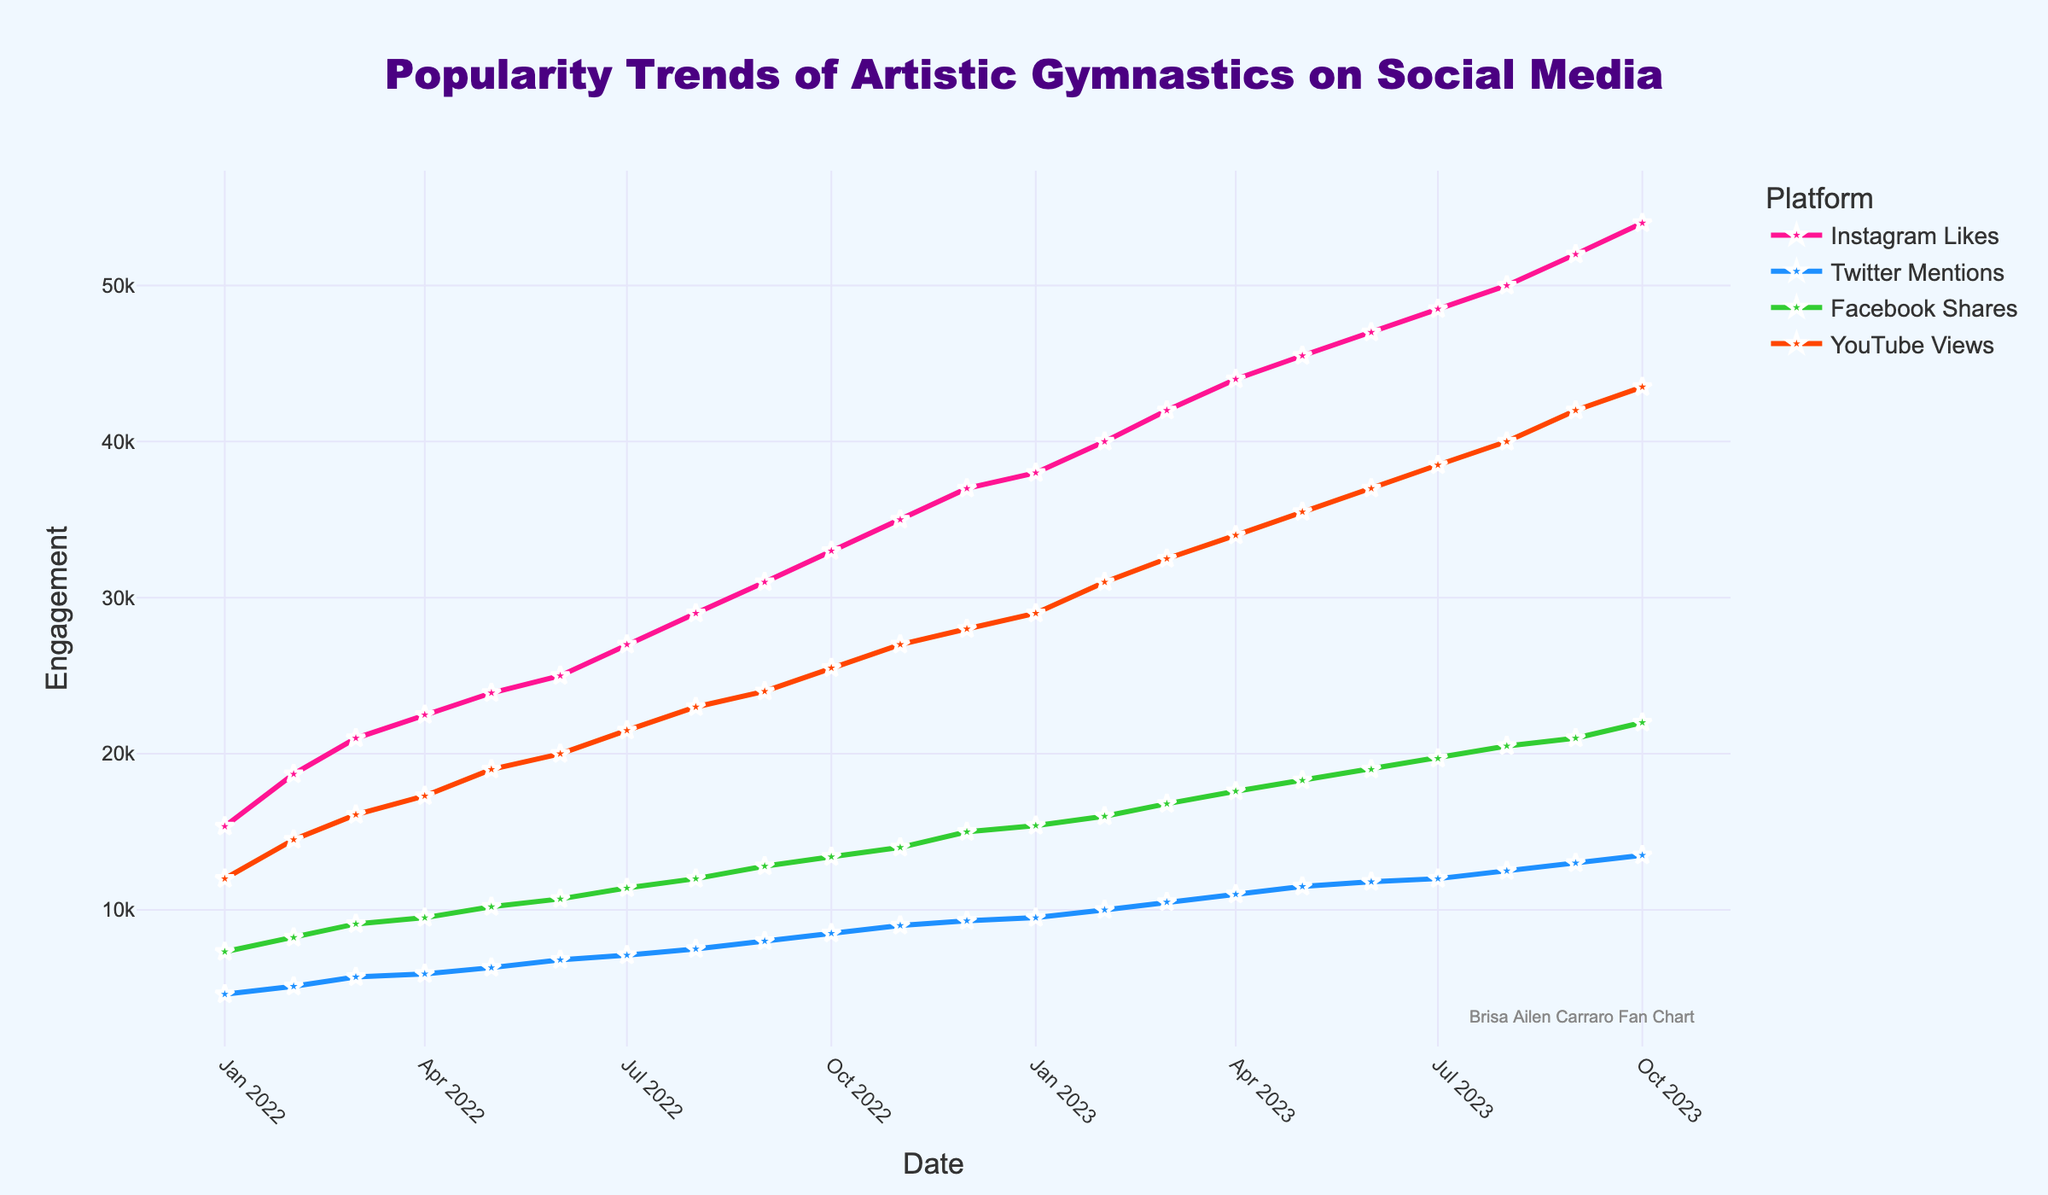What's the title of the figure? The title is located at the top center of the figure and reads "Popularity Trends of Artistic Gymnastics on Social Media."
Answer: Popularity Trends of Artistic Gymnastics on Social Media How many unique social media platforms are presented in the figure? There are four distinct lines in the figure, each representing a different social media platform as indicated in the legend.
Answer: 4 Which social media platform has the highest engagement overall by the end of the time period? By looking at the end of the time series (October 2023), the highest line corresponds to Instagram Likes, indicating it has the highest engagement.
Answer: Instagram Likes What is the range of Twitter mentions from January 2022 to October 2023? The lowest value is in January 2022 with 4600 mentions, and the highest value is in October 2023 with 13500 mentions. The range is 13500 - 4600.
Answer: 8900 Did the engagement on Facebook Shares ever surpass Instagram Likes during this period? By comparing the lines of Facebook Shares and Instagram Likes over the time series, it is clear that Instagram Likes are always higher at each month.
Answer: No Which month shows the largest increase in YouTube Views? To find the largest increase, compute the differences month-to-month for YouTube Views and find the maximum. From Feb 2023 (31000) to March 2023 (32500), it's an increase of 1500, which is the highest.
Answer: March 2023 How does the engagement on Facebook Shares change from June 2022 to January 2023? Starting at 10700 in June 2022 and increasing to 15400 in January 2023, the difference is 15400 - 10700.
Answer: 4700 On which social media platform did the engagement grow the fastest between January 2022 and October 2023? By calculating the growth for each platform, Instagram Likes grew from 15350 to 54000, the highest absolute increase.
Answer: Instagram Likes Was there any month where Twitter Mentions had a noticeable spike compared to previous months? A noticeable spike is defined as a larger than usual increase. Going from April 2023 to May 2023, Twitter Mentions increased by 500, while typical increases were around 400.
Answer: May 2023 What is the cumulative increase in YouTube Views from January 2022 to October 2023? The increase in views is the difference between the start and end values: 43500 - 12000.
Answer: 31500 